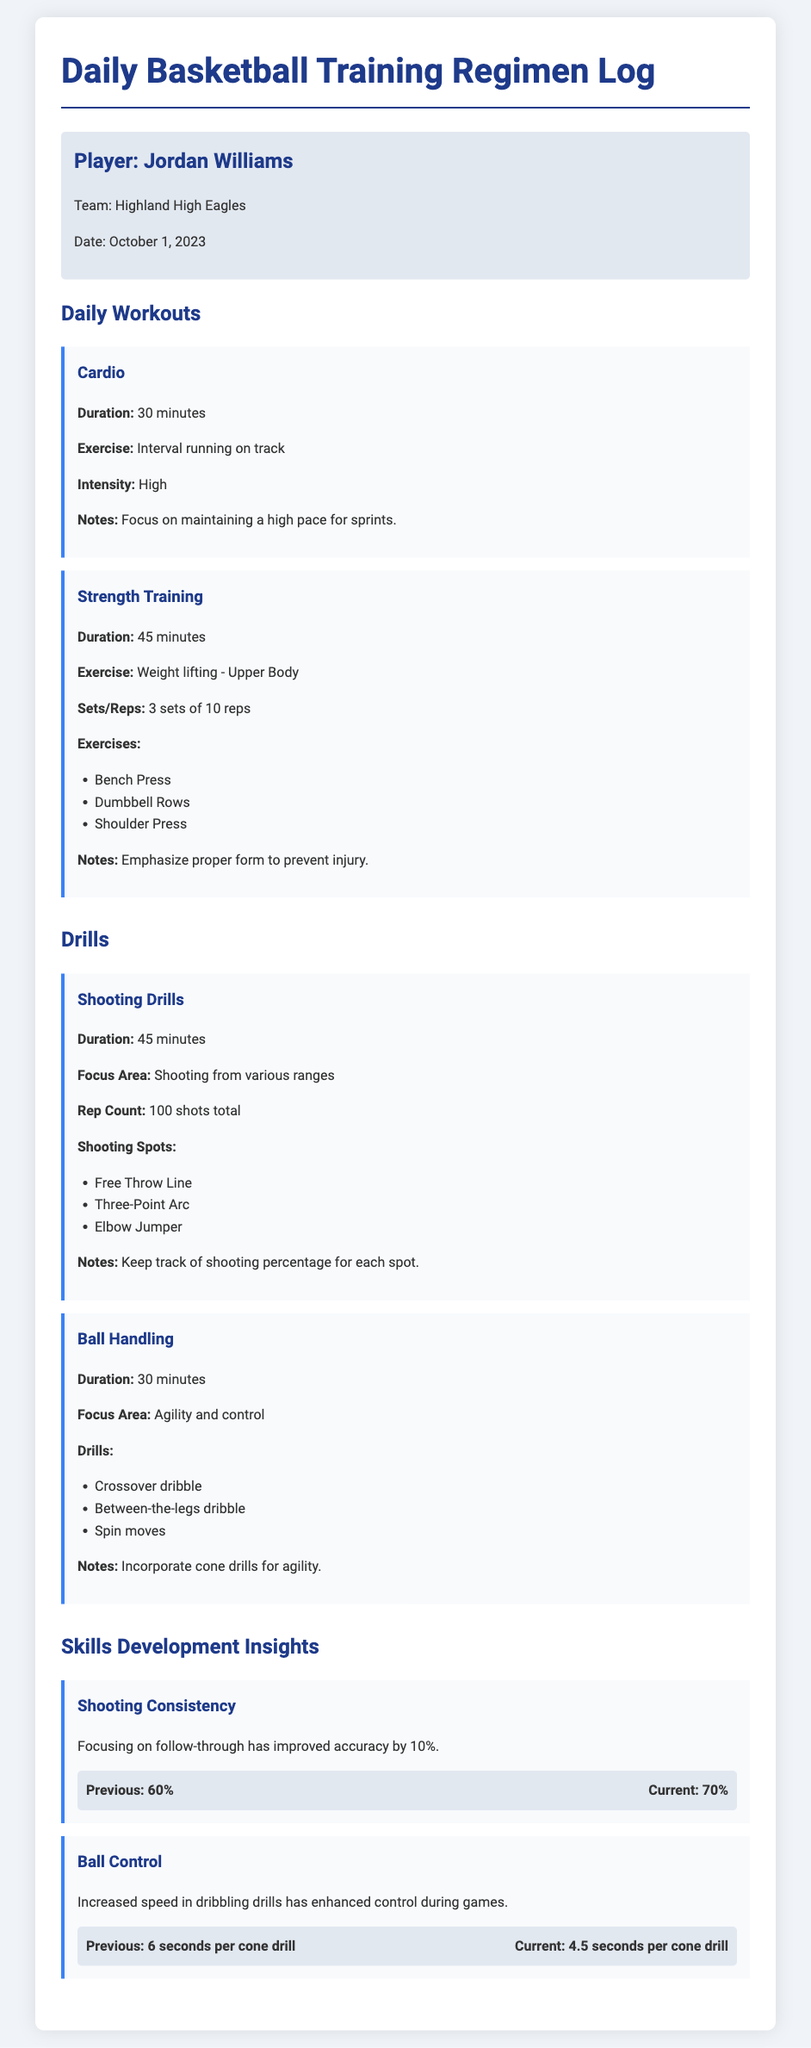What is the player's name? The player's name is mentioned in the player info section of the document.
Answer: Jordan Williams What date is recorded in the log? The date reflects when the training session occurred, as noted in the player info section.
Answer: October 1, 2023 How long was the cardio workout? The duration of the cardio workout is specified in the daily workouts section.
Answer: 30 minutes What is the total number of shots taken in the shooting drills? The total number of shots is listed under the shooting drills in the drills section of the document.
Answer: 100 shots What was the player's shooting accuracy improvement percentage? The improvement is documented in the skills development insights section regarding shooting consistency.
Answer: 10% How many sets and reps were performed in strength training? The sets and reps are detailed in the strength training section under daily workouts.
Answer: 3 sets of 10 reps What is the focus area of the ball handling drills? The focus area for ball handling is specified in the drills section of the document.
Answer: Agility and control How has the cone drill time changed? The previous and current times are compared in the skills development insights section under ball control.
Answer: 1.5 seconds less What exercise is repeated in the upper body strength training? The specific exercises are enumerated in the strength training section.
Answer: Dumbbell Rows 